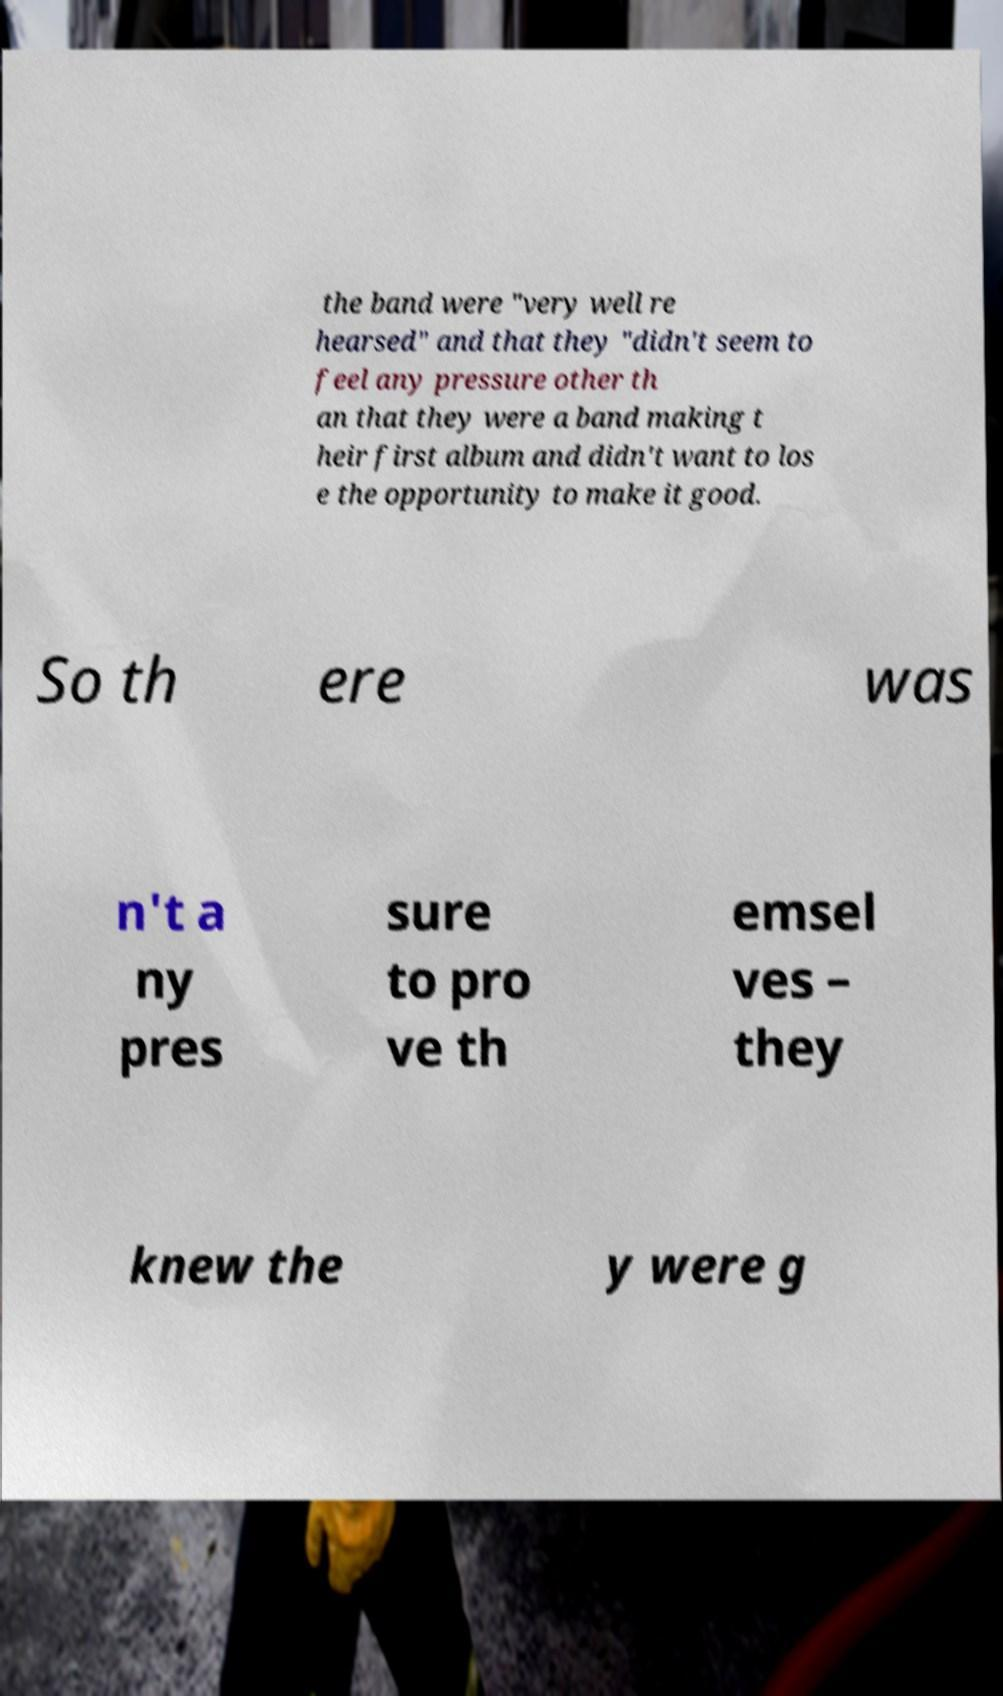Can you read and provide the text displayed in the image?This photo seems to have some interesting text. Can you extract and type it out for me? the band were "very well re hearsed" and that they "didn't seem to feel any pressure other th an that they were a band making t heir first album and didn't want to los e the opportunity to make it good. So th ere was n't a ny pres sure to pro ve th emsel ves – they knew the y were g 